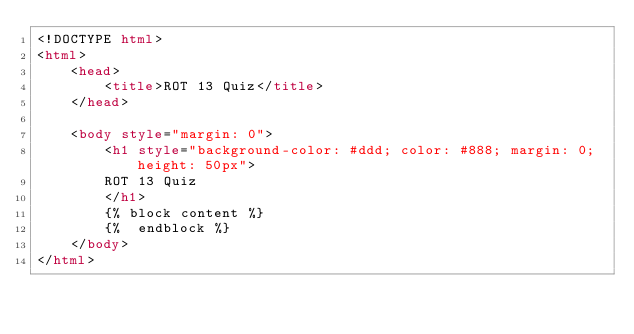<code> <loc_0><loc_0><loc_500><loc_500><_HTML_><!DOCTYPE html>
<html>
    <head>
        <title>ROT 13 Quiz</title>
    </head>

    <body style="margin: 0">
        <h1 style="background-color: #ddd; color: #888; margin: 0; height: 50px">
        ROT 13 Quiz
        </h1>
        {% block content %}
        {%  endblock %}
    </body>
</html></code> 